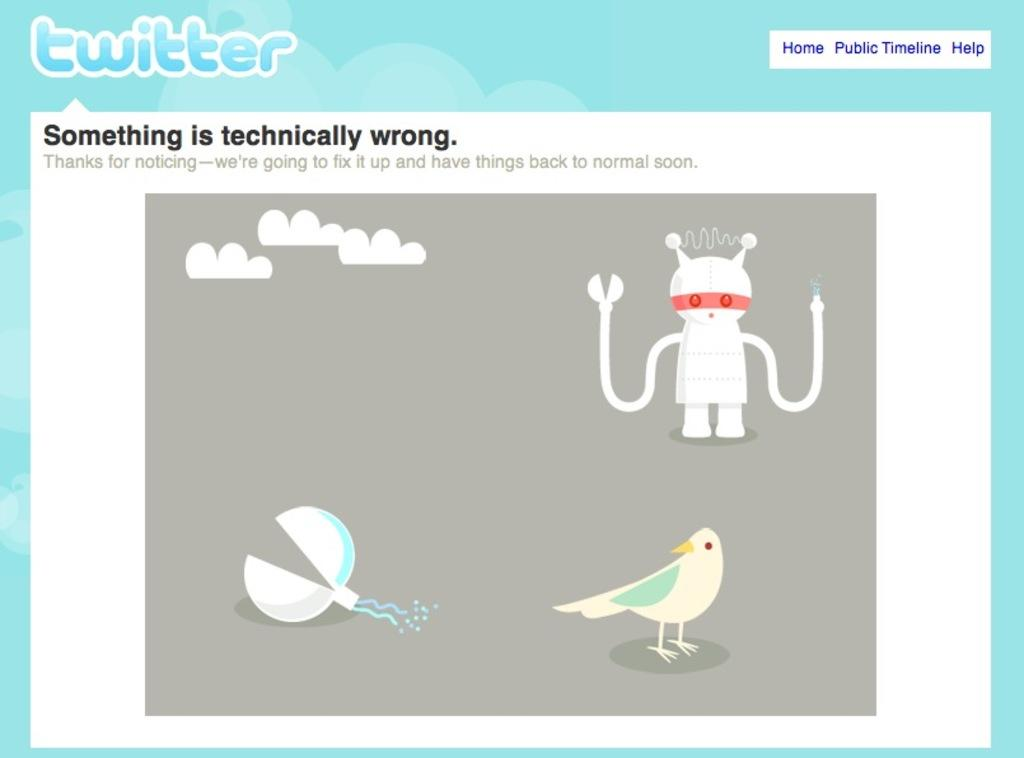What type of visual is the image? The image is a poster. What can be found on the poster besides images? There are texts written on the poster. What kind of characters are present on the poster? There are cartoon figures on the poster. What else is depicted on the poster besides characters? There are objects depicted on the poster. Can you describe one of the cartoon figures on the poster? There is a cartoon bird on the poster. What season is depicted in the poster? The provided facts do not mention any season, so it cannot be determined from the image. What type of rhythm can be heard in the poster? The poster is a visual medium, so there is no audible rhythm present. 